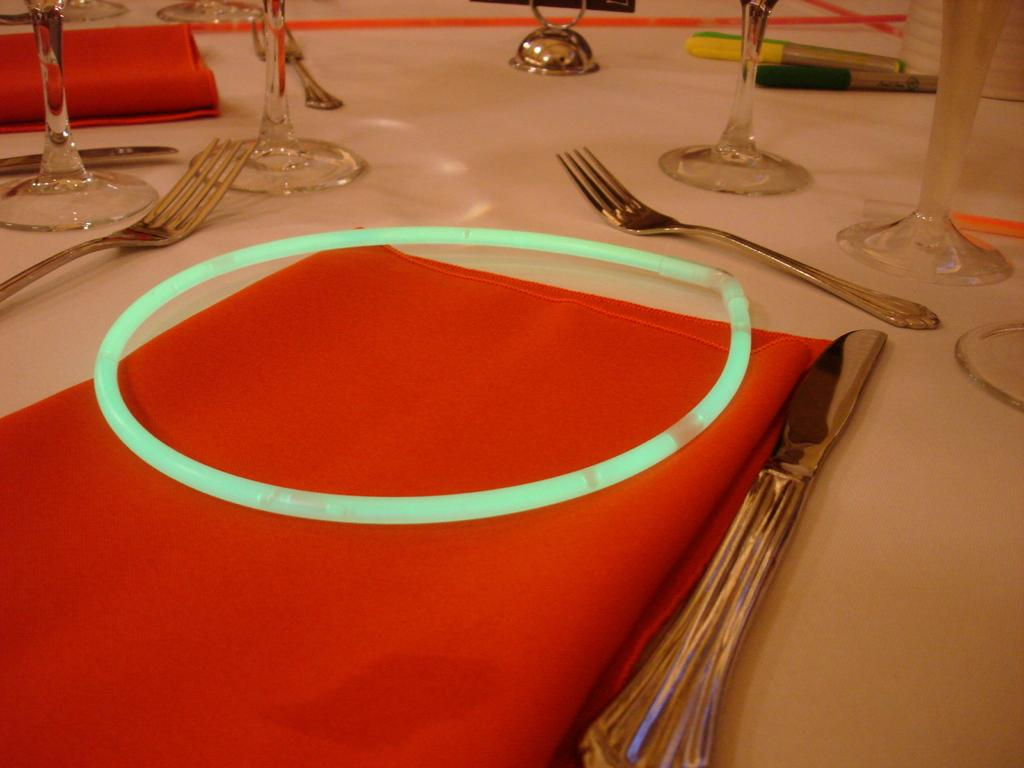What color are the clothes in the image? The clothes in the image are red. What type of objects can be seen in the image? Glasses, forks, and a circular shaped object on a red cloth are visible in the image. What is the color of the surface on which the objects are placed? The objects are placed on a white surface. Can you describe the circular shaped object in the foreground? The circular shaped object is on a red cloth in the foreground. What type of wood is used to make the credit card in the image? There is no credit card present in the image, and therefore no wood can be associated with it. 